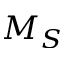<formula> <loc_0><loc_0><loc_500><loc_500>M _ { S }</formula> 